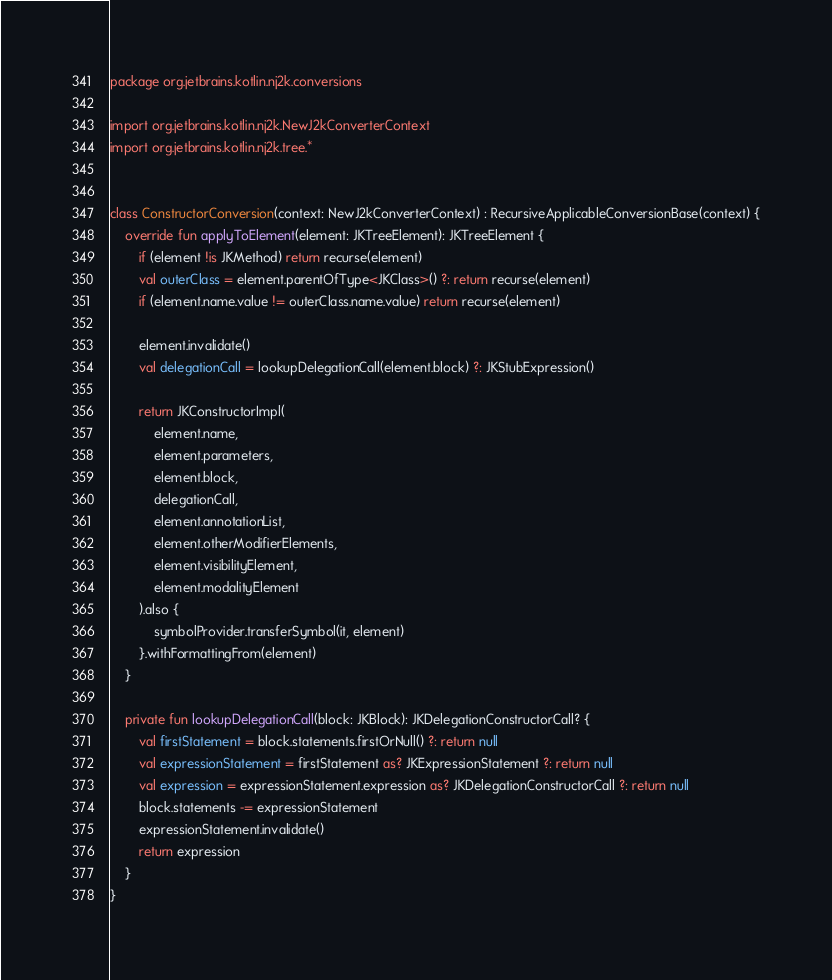<code> <loc_0><loc_0><loc_500><loc_500><_Kotlin_>package org.jetbrains.kotlin.nj2k.conversions

import org.jetbrains.kotlin.nj2k.NewJ2kConverterContext
import org.jetbrains.kotlin.nj2k.tree.*


class ConstructorConversion(context: NewJ2kConverterContext) : RecursiveApplicableConversionBase(context) {
    override fun applyToElement(element: JKTreeElement): JKTreeElement {
        if (element !is JKMethod) return recurse(element)
        val outerClass = element.parentOfType<JKClass>() ?: return recurse(element)
        if (element.name.value != outerClass.name.value) return recurse(element)

        element.invalidate()
        val delegationCall = lookupDelegationCall(element.block) ?: JKStubExpression()

        return JKConstructorImpl(
            element.name,
            element.parameters,
            element.block,
            delegationCall,
            element.annotationList,
            element.otherModifierElements,
            element.visibilityElement,
            element.modalityElement
        ).also {
            symbolProvider.transferSymbol(it, element)
        }.withFormattingFrom(element)
    }

    private fun lookupDelegationCall(block: JKBlock): JKDelegationConstructorCall? {
        val firstStatement = block.statements.firstOrNull() ?: return null
        val expressionStatement = firstStatement as? JKExpressionStatement ?: return null
        val expression = expressionStatement.expression as? JKDelegationConstructorCall ?: return null
        block.statements -= expressionStatement
        expressionStatement.invalidate()
        return expression
    }
}</code> 